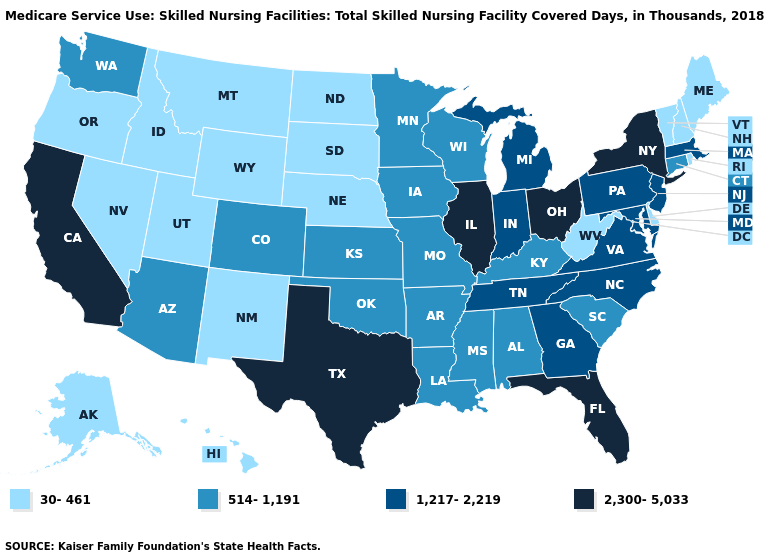Among the states that border New Mexico , which have the lowest value?
Write a very short answer. Utah. Among the states that border New Mexico , which have the highest value?
Concise answer only. Texas. Is the legend a continuous bar?
Write a very short answer. No. Does Connecticut have the highest value in the USA?
Short answer required. No. What is the value of New Jersey?
Quick response, please. 1,217-2,219. Name the states that have a value in the range 514-1,191?
Be succinct. Alabama, Arizona, Arkansas, Colorado, Connecticut, Iowa, Kansas, Kentucky, Louisiana, Minnesota, Mississippi, Missouri, Oklahoma, South Carolina, Washington, Wisconsin. What is the value of Oregon?
Write a very short answer. 30-461. Which states have the highest value in the USA?
Concise answer only. California, Florida, Illinois, New York, Ohio, Texas. Name the states that have a value in the range 1,217-2,219?
Be succinct. Georgia, Indiana, Maryland, Massachusetts, Michigan, New Jersey, North Carolina, Pennsylvania, Tennessee, Virginia. Which states have the lowest value in the South?
Quick response, please. Delaware, West Virginia. Is the legend a continuous bar?
Answer briefly. No. Among the states that border Minnesota , which have the lowest value?
Give a very brief answer. North Dakota, South Dakota. Which states have the highest value in the USA?
Concise answer only. California, Florida, Illinois, New York, Ohio, Texas. What is the value of Wyoming?
Short answer required. 30-461. Name the states that have a value in the range 2,300-5,033?
Concise answer only. California, Florida, Illinois, New York, Ohio, Texas. 